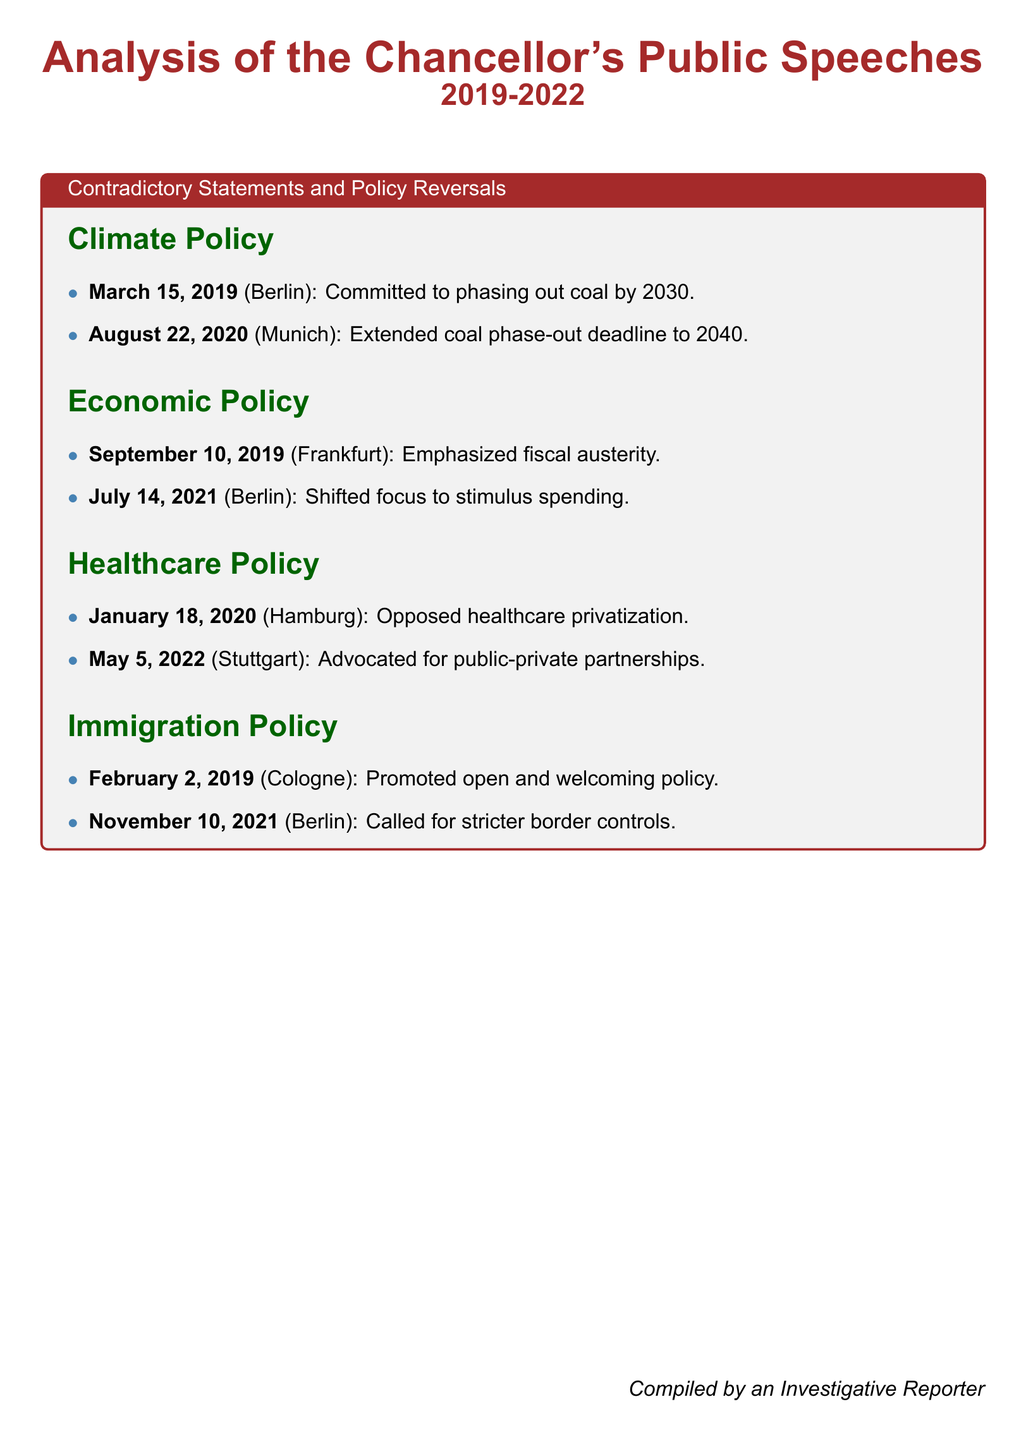What was the original coal phase-out deadline? The original coal phase-out deadline was committed to being 2030.
Answer: 2030 When did the Chancellor advocate for public-private partnerships in healthcare? The Chancellor advocated for public-private partnerships in healthcare on May 5, 2022.
Answer: May 5, 2022 What city was the Chancellor in when calling for stricter border controls? The Chancellor was in Berlin when calling for stricter border controls.
Answer: Berlin What shift in economic focus was stated in July 2021? The shift in economic focus stated in July 2021 was to stimulus spending.
Answer: Stimulus spending What was the Chancellor's stance on healthcare privatization in January 2020? The stance on healthcare privatization in January 2020 was opposition.
Answer: Opposed When was the extended coal phase-out deadline announced? The extended coal phase-out deadline was announced on August 22, 2020.
Answer: August 22, 2020 What policy did the Chancellor promote on February 2, 2019? The policy promoted on February 2, 2019 was open and welcoming.
Answer: Open and welcoming What is the total number of contradictory statements listed in the document? The total number of contradictory statements listed is four.
Answer: Four What date did the Chancellor emphasize fiscal austerity? The Chancellor emphasized fiscal austerity on September 10, 2019.
Answer: September 10, 2019 